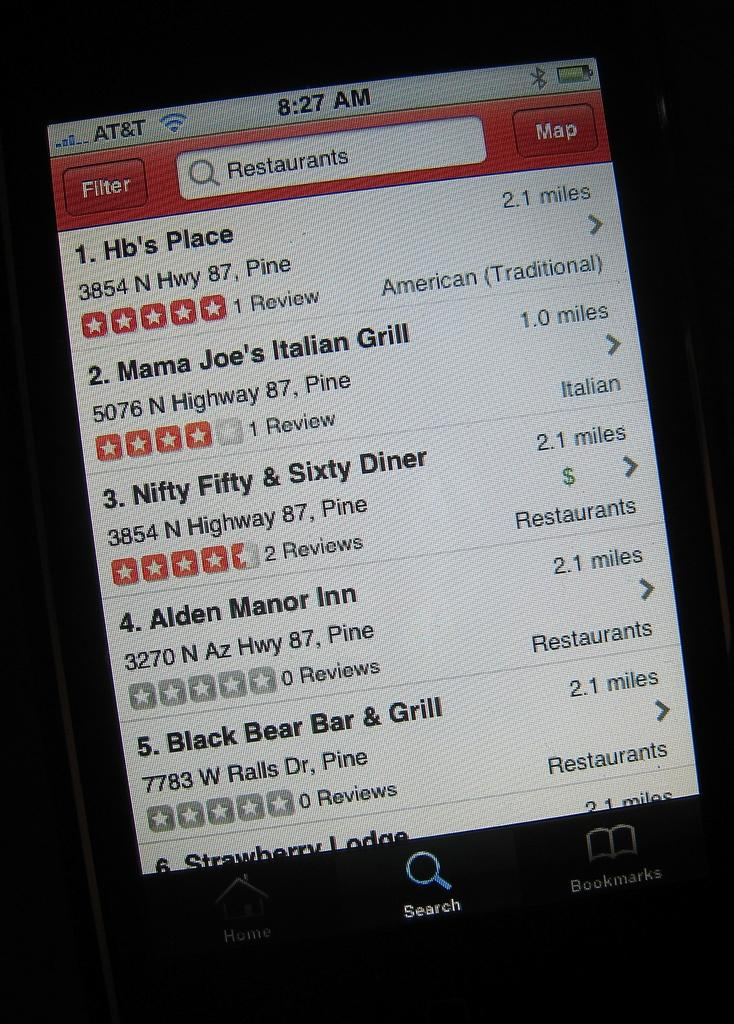<image>
Share a concise interpretation of the image provided. A phone screen shows that someone searched for restaurants and the results include Hb's Place and Mama Joe's Italian Diner. 